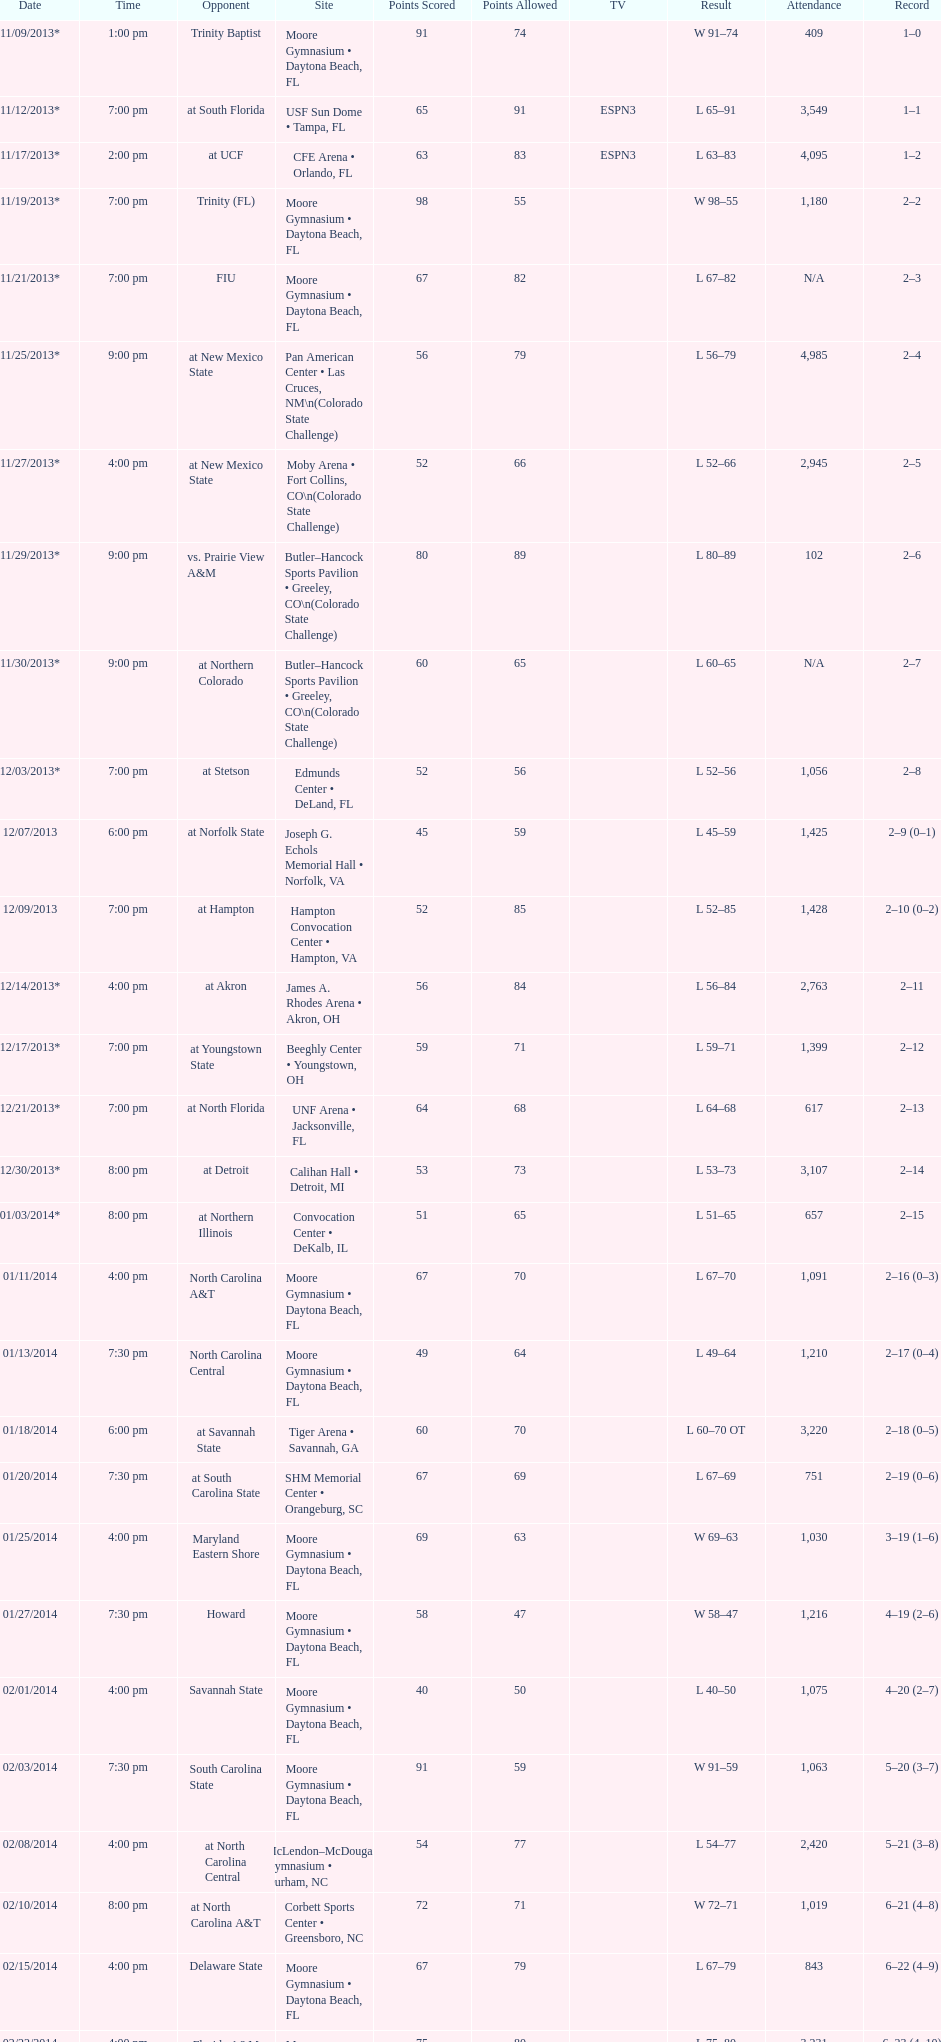How many games had more than 1,500 in attendance? 12. Could you help me parse every detail presented in this table? {'header': ['Date', 'Time', 'Opponent', 'Site', 'Points Scored', 'Points Allowed', 'TV', 'Result', 'Attendance', 'Record'], 'rows': [['11/09/2013*', '1:00 pm', 'Trinity Baptist', 'Moore Gymnasium • Daytona Beach, FL', '91', '74', '', 'W\xa091–74', '409', '1–0'], ['11/12/2013*', '7:00 pm', 'at\xa0South Florida', 'USF Sun Dome • Tampa, FL', '65', '91', 'ESPN3', 'L\xa065–91', '3,549', '1–1'], ['11/17/2013*', '2:00 pm', 'at\xa0UCF', 'CFE Arena • Orlando, FL', '63', '83', 'ESPN3', 'L\xa063–83', '4,095', '1–2'], ['11/19/2013*', '7:00 pm', 'Trinity (FL)', 'Moore Gymnasium • Daytona Beach, FL', '98', '55', '', 'W\xa098–55', '1,180', '2–2'], ['11/21/2013*', '7:00 pm', 'FIU', 'Moore Gymnasium • Daytona Beach, FL', '67', '82', '', 'L\xa067–82', 'N/A', '2–3'], ['11/25/2013*', '9:00 pm', 'at\xa0New Mexico State', 'Pan American Center • Las Cruces, NM\\n(Colorado State Challenge)', '56', '79', '', 'L\xa056–79', '4,985', '2–4'], ['11/27/2013*', '4:00 pm', 'at\xa0New Mexico State', 'Moby Arena • Fort Collins, CO\\n(Colorado State Challenge)', '52', '66', '', 'L\xa052–66', '2,945', '2–5'], ['11/29/2013*', '9:00 pm', 'vs.\xa0Prairie View A&M', 'Butler–Hancock Sports Pavilion • Greeley, CO\\n(Colorado State Challenge)', '80', '89', '', 'L\xa080–89', '102', '2–6'], ['11/30/2013*', '9:00 pm', 'at\xa0Northern Colorado', 'Butler–Hancock Sports Pavilion • Greeley, CO\\n(Colorado State Challenge)', '60', '65', '', 'L\xa060–65', 'N/A', '2–7'], ['12/03/2013*', '7:00 pm', 'at\xa0Stetson', 'Edmunds Center • DeLand, FL', '52', '56', '', 'L\xa052–56', '1,056', '2–8'], ['12/07/2013', '6:00 pm', 'at\xa0Norfolk State', 'Joseph G. Echols Memorial Hall • Norfolk, VA', '45', '59', '', 'L\xa045–59', '1,425', '2–9 (0–1)'], ['12/09/2013', '7:00 pm', 'at\xa0Hampton', 'Hampton Convocation Center • Hampton, VA', '52', '85', '', 'L\xa052–85', '1,428', '2–10 (0–2)'], ['12/14/2013*', '4:00 pm', 'at\xa0Akron', 'James A. Rhodes Arena • Akron, OH', '56', '84', '', 'L\xa056–84', '2,763', '2–11'], ['12/17/2013*', '7:00 pm', 'at\xa0Youngstown State', 'Beeghly Center • Youngstown, OH', '59', '71', '', 'L\xa059–71', '1,399', '2–12'], ['12/21/2013*', '7:00 pm', 'at\xa0North Florida', 'UNF Arena • Jacksonville, FL', '64', '68', '', 'L\xa064–68', '617', '2–13'], ['12/30/2013*', '8:00 pm', 'at\xa0Detroit', 'Calihan Hall • Detroit, MI', '53', '73', '', 'L\xa053–73', '3,107', '2–14'], ['01/03/2014*', '8:00 pm', 'at\xa0Northern Illinois', 'Convocation Center • DeKalb, IL', '51', '65', '', 'L\xa051–65', '657', '2–15'], ['01/11/2014', '4:00 pm', 'North Carolina A&T', 'Moore Gymnasium • Daytona Beach, FL', '67', '70', '', 'L\xa067–70', '1,091', '2–16 (0–3)'], ['01/13/2014', '7:30 pm', 'North Carolina Central', 'Moore Gymnasium • Daytona Beach, FL', '49', '64', '', 'L\xa049–64', '1,210', '2–17 (0–4)'], ['01/18/2014', '6:00 pm', 'at\xa0Savannah State', 'Tiger Arena • Savannah, GA', '60', '70', '', 'L\xa060–70\xa0OT', '3,220', '2–18 (0–5)'], ['01/20/2014', '7:30 pm', 'at\xa0South Carolina State', 'SHM Memorial Center • Orangeburg, SC', '67', '69', '', 'L\xa067–69', '751', '2–19 (0–6)'], ['01/25/2014', '4:00 pm', 'Maryland Eastern Shore', 'Moore Gymnasium • Daytona Beach, FL', '69', '63', '', 'W\xa069–63', '1,030', '3–19 (1–6)'], ['01/27/2014', '7:30 pm', 'Howard', 'Moore Gymnasium • Daytona Beach, FL', '58', '47', '', 'W\xa058–47', '1,216', '4–19 (2–6)'], ['02/01/2014', '4:00 pm', 'Savannah State', 'Moore Gymnasium • Daytona Beach, FL', '40', '50', '', 'L\xa040–50', '1,075', '4–20 (2–7)'], ['02/03/2014', '7:30 pm', 'South Carolina State', 'Moore Gymnasium • Daytona Beach, FL', '91', '59', '', 'W\xa091–59', '1,063', '5–20 (3–7)'], ['02/08/2014', '4:00 pm', 'at\xa0North Carolina Central', 'McLendon–McDougald Gymnasium • Durham, NC', '54', '77', '', 'L\xa054–77', '2,420', '5–21 (3–8)'], ['02/10/2014', '8:00 pm', 'at\xa0North Carolina A&T', 'Corbett Sports Center • Greensboro, NC', '72', '71', '', 'W\xa072–71', '1,019', '6–21 (4–8)'], ['02/15/2014', '4:00 pm', 'Delaware State', 'Moore Gymnasium • Daytona Beach, FL', '67', '79', '', 'L\xa067–79', '843', '6–22 (4–9)'], ['02/22/2014', '4:00 pm', 'Florida A&M', 'Moore Gymnasium • Daytona Beach, FL', '75', '80', '', 'L\xa075–80', '3,231', '6–23 (4–10)'], ['03/01/2014', '4:00 pm', 'at\xa0Morgan State', 'Talmadge L. Hill Field House • Baltimore, MD', '61', '65', '', 'L\xa061–65', '2,056', '6–24 (4–11)'], ['03/06/2014', '7:30 pm', 'at\xa0Florida A&M', 'Teaching Gym • Tallahassee, FL', '70', '68', '', 'W\xa070–68', '2,376', '7–24 (5–11)'], ['03/11/2014', '6:30 pm', 'vs.\xa0Coppin State', 'Norfolk Scope • Norfolk, VA\\n(First round)', '68', '75', '', 'L\xa068–75', '4,658', '7–25']]} 